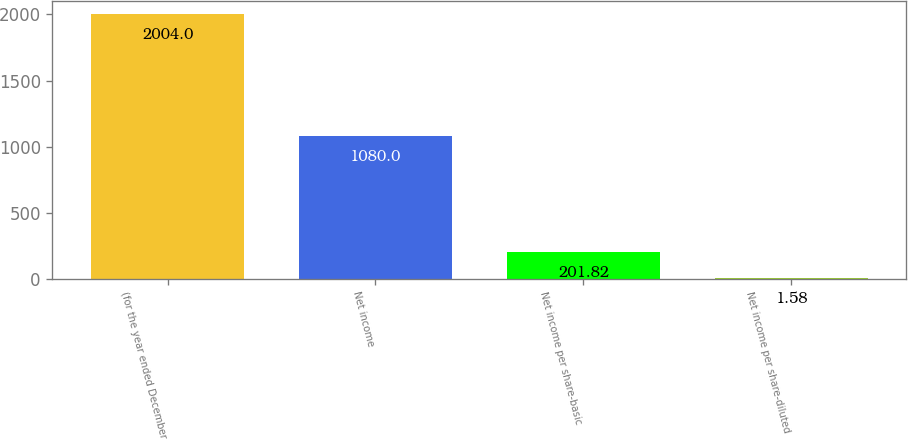<chart> <loc_0><loc_0><loc_500><loc_500><bar_chart><fcel>(for the year ended December<fcel>Net income<fcel>Net income per share-basic<fcel>Net income per share-diluted<nl><fcel>2004<fcel>1080<fcel>201.82<fcel>1.58<nl></chart> 